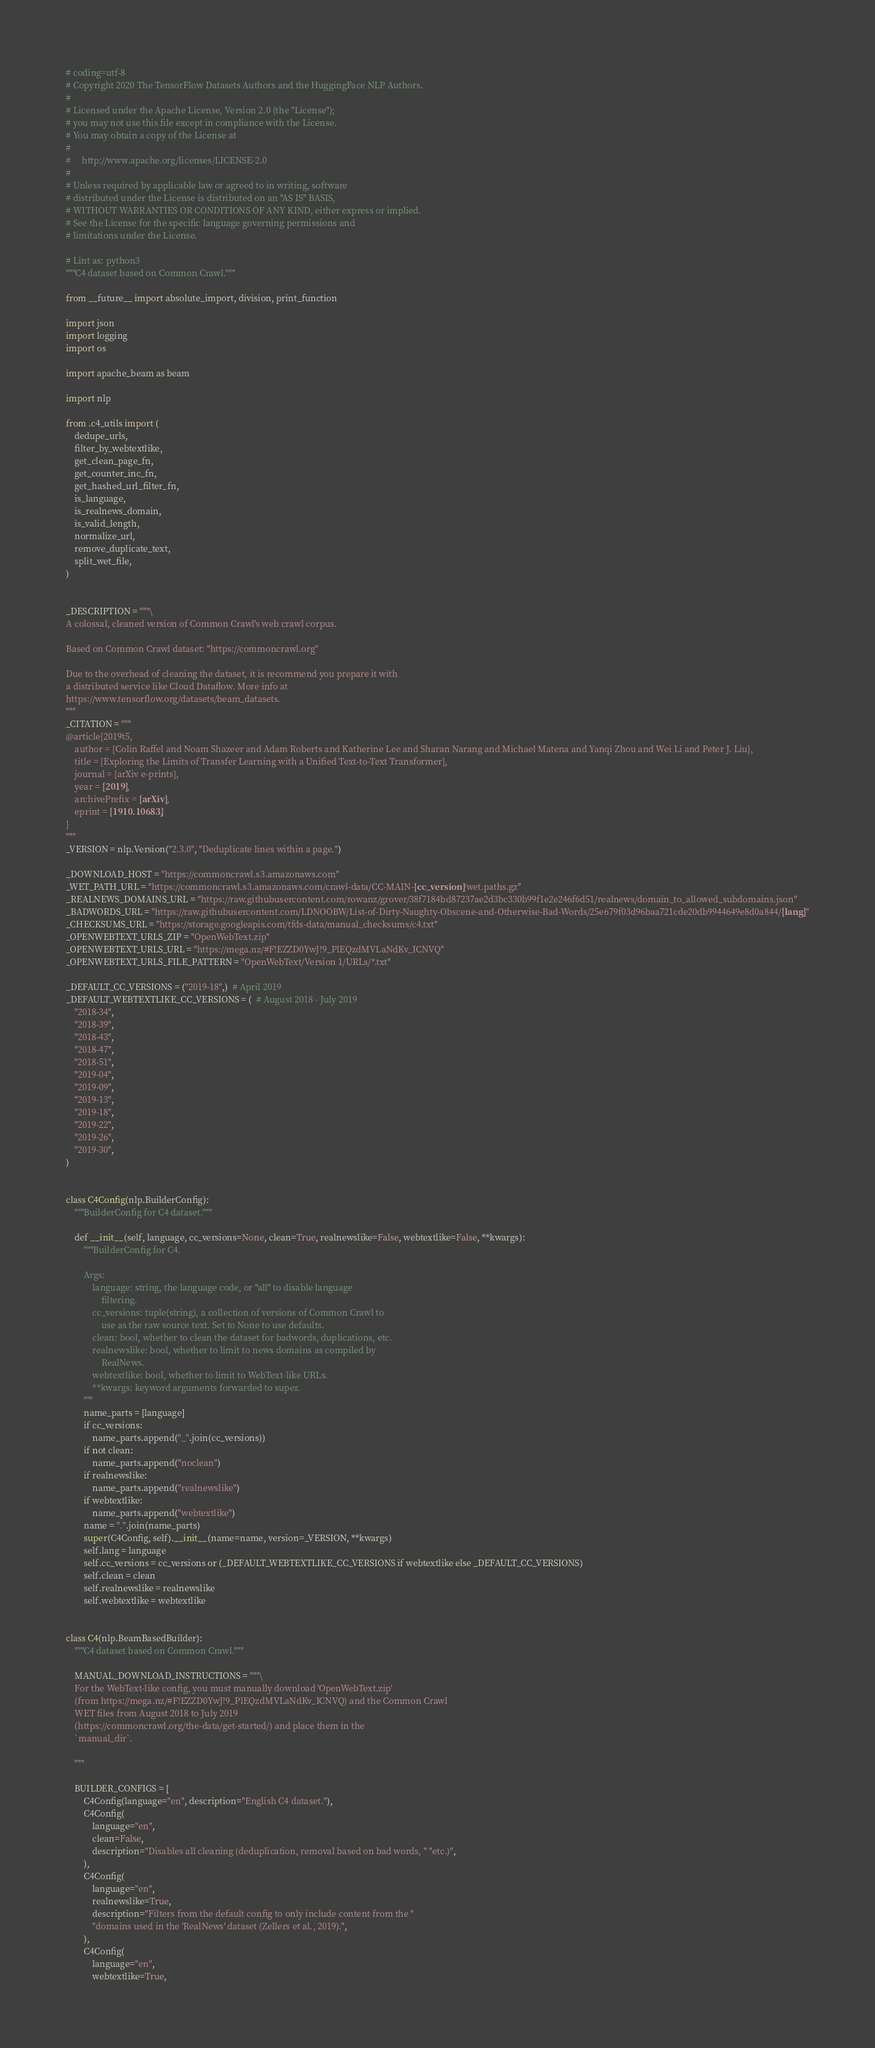<code> <loc_0><loc_0><loc_500><loc_500><_Python_># coding=utf-8
# Copyright 2020 The TensorFlow Datasets Authors and the HuggingFace NLP Authors.
#
# Licensed under the Apache License, Version 2.0 (the "License");
# you may not use this file except in compliance with the License.
# You may obtain a copy of the License at
#
#     http://www.apache.org/licenses/LICENSE-2.0
#
# Unless required by applicable law or agreed to in writing, software
# distributed under the License is distributed on an "AS IS" BASIS,
# WITHOUT WARRANTIES OR CONDITIONS OF ANY KIND, either express or implied.
# See the License for the specific language governing permissions and
# limitations under the License.

# Lint as: python3
"""C4 dataset based on Common Crawl."""

from __future__ import absolute_import, division, print_function

import json
import logging
import os

import apache_beam as beam

import nlp

from .c4_utils import (
    dedupe_urls,
    filter_by_webtextlike,
    get_clean_page_fn,
    get_counter_inc_fn,
    get_hashed_url_filter_fn,
    is_language,
    is_realnews_domain,
    is_valid_length,
    normalize_url,
    remove_duplicate_text,
    split_wet_file,
)


_DESCRIPTION = """\
A colossal, cleaned version of Common Crawl's web crawl corpus.

Based on Common Crawl dataset: "https://commoncrawl.org"

Due to the overhead of cleaning the dataset, it is recommend you prepare it with
a distributed service like Cloud Dataflow. More info at
https://www.tensorflow.org/datasets/beam_datasets.
"""
_CITATION = """
@article{2019t5,
    author = {Colin Raffel and Noam Shazeer and Adam Roberts and Katherine Lee and Sharan Narang and Michael Matena and Yanqi Zhou and Wei Li and Peter J. Liu},
    title = {Exploring the Limits of Transfer Learning with a Unified Text-to-Text Transformer},
    journal = {arXiv e-prints},
    year = {2019},
    archivePrefix = {arXiv},
    eprint = {1910.10683},
}
"""
_VERSION = nlp.Version("2.3.0", "Deduplicate lines within a page.")

_DOWNLOAD_HOST = "https://commoncrawl.s3.amazonaws.com"
_WET_PATH_URL = "https://commoncrawl.s3.amazonaws.com/crawl-data/CC-MAIN-{cc_version}/wet.paths.gz"
_REALNEWS_DOMAINS_URL = "https://raw.githubusercontent.com/rowanz/grover/38f7184bd87237ae2d3bc330b99f1e2e246f6d51/realnews/domain_to_allowed_subdomains.json"
_BADWORDS_URL = "https://raw.githubusercontent.com/LDNOOBW/List-of-Dirty-Naughty-Obscene-and-Otherwise-Bad-Words/25e679f03d96baa721cde20db9944649e8d0a844/{lang}"
_CHECKSUMS_URL = "https://storage.googleapis.com/tfds-data/manual_checksums/c4.txt"
_OPENWEBTEXT_URLS_ZIP = "OpenWebText.zip"
_OPENWEBTEXT_URLS_URL = "https://mega.nz/#F!EZZD0YwJ!9_PlEQzdMVLaNdKv_ICNVQ"
_OPENWEBTEXT_URLS_FILE_PATTERN = "OpenWebText/Version 1/URLs/*.txt"

_DEFAULT_CC_VERSIONS = ("2019-18",)  # April 2019
_DEFAULT_WEBTEXTLIKE_CC_VERSIONS = (  # August 2018 - July 2019
    "2018-34",
    "2018-39",
    "2018-43",
    "2018-47",
    "2018-51",
    "2019-04",
    "2019-09",
    "2019-13",
    "2019-18",
    "2019-22",
    "2019-26",
    "2019-30",
)


class C4Config(nlp.BuilderConfig):
    """BuilderConfig for C4 dataset."""

    def __init__(self, language, cc_versions=None, clean=True, realnewslike=False, webtextlike=False, **kwargs):
        """BuilderConfig for C4.

        Args:
            language: string, the language code, or "all" to disable language
                filtering.
            cc_versions: tuple(string), a collection of versions of Common Crawl to
                use as the raw source text. Set to None to use defaults.
            clean: bool, whether to clean the dataset for badwords, duplications, etc.
            realnewslike: bool, whether to limit to news domains as compiled by
                RealNews.
            webtextlike: bool, whether to limit to WebText-like URLs.
            **kwargs: keyword arguments forwarded to super.
        """
        name_parts = [language]
        if cc_versions:
            name_parts.append("_".join(cc_versions))
        if not clean:
            name_parts.append("noclean")
        if realnewslike:
            name_parts.append("realnewslike")
        if webtextlike:
            name_parts.append("webtextlike")
        name = ".".join(name_parts)
        super(C4Config, self).__init__(name=name, version=_VERSION, **kwargs)
        self.lang = language
        self.cc_versions = cc_versions or (_DEFAULT_WEBTEXTLIKE_CC_VERSIONS if webtextlike else _DEFAULT_CC_VERSIONS)
        self.clean = clean
        self.realnewslike = realnewslike
        self.webtextlike = webtextlike


class C4(nlp.BeamBasedBuilder):
    """C4 dataset based on Common Crawl."""

    MANUAL_DOWNLOAD_INSTRUCTIONS = """\
    For the WebText-like config, you must manually download 'OpenWebText.zip'
    (from https://mega.nz/#F!EZZD0YwJ!9_PlEQzdMVLaNdKv_ICNVQ) and the Common Crawl
    WET files from August 2018 to July 2019
    (https://commoncrawl.org/the-data/get-started/) and place them in the
    `manual_dir`.

    """

    BUILDER_CONFIGS = [
        C4Config(language="en", description="English C4 dataset."),
        C4Config(
            language="en",
            clean=False,
            description="Disables all cleaning (deduplication, removal based on bad words, " "etc.)",
        ),
        C4Config(
            language="en",
            realnewslike=True,
            description="Filters from the default config to only include content from the "
            "domains used in the 'RealNews' dataset (Zellers et al., 2019).",
        ),
        C4Config(
            language="en",
            webtextlike=True,</code> 